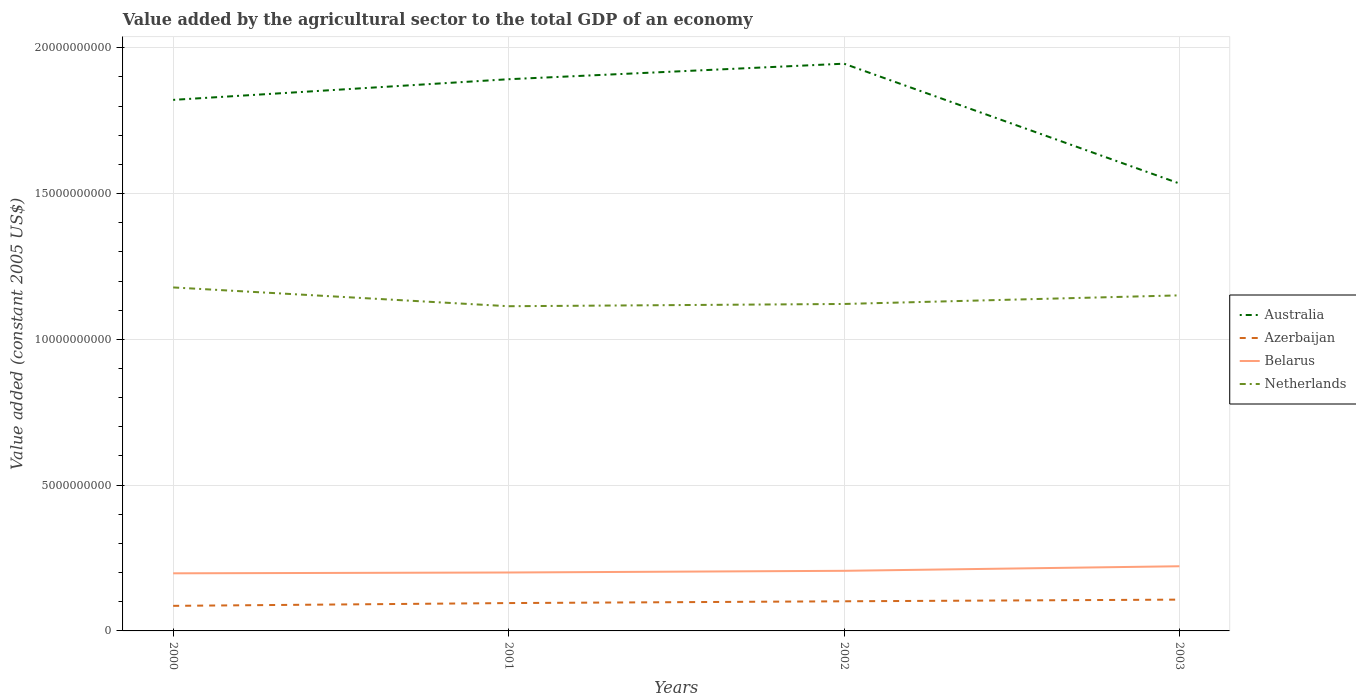How many different coloured lines are there?
Give a very brief answer. 4. Across all years, what is the maximum value added by the agricultural sector in Azerbaijan?
Ensure brevity in your answer.  8.60e+08. In which year was the value added by the agricultural sector in Azerbaijan maximum?
Make the answer very short. 2000. What is the total value added by the agricultural sector in Australia in the graph?
Your answer should be compact. 2.87e+09. What is the difference between the highest and the second highest value added by the agricultural sector in Belarus?
Provide a succinct answer. 2.42e+08. Is the value added by the agricultural sector in Azerbaijan strictly greater than the value added by the agricultural sector in Australia over the years?
Provide a short and direct response. Yes. How many years are there in the graph?
Ensure brevity in your answer.  4. Where does the legend appear in the graph?
Provide a short and direct response. Center right. What is the title of the graph?
Your answer should be very brief. Value added by the agricultural sector to the total GDP of an economy. What is the label or title of the Y-axis?
Provide a short and direct response. Value added (constant 2005 US$). What is the Value added (constant 2005 US$) of Australia in 2000?
Your answer should be compact. 1.82e+1. What is the Value added (constant 2005 US$) in Azerbaijan in 2000?
Your response must be concise. 8.60e+08. What is the Value added (constant 2005 US$) of Belarus in 2000?
Offer a terse response. 1.98e+09. What is the Value added (constant 2005 US$) of Netherlands in 2000?
Provide a short and direct response. 1.18e+1. What is the Value added (constant 2005 US$) in Australia in 2001?
Offer a terse response. 1.89e+1. What is the Value added (constant 2005 US$) of Azerbaijan in 2001?
Ensure brevity in your answer.  9.55e+08. What is the Value added (constant 2005 US$) of Belarus in 2001?
Your answer should be very brief. 2.00e+09. What is the Value added (constant 2005 US$) in Netherlands in 2001?
Your response must be concise. 1.11e+1. What is the Value added (constant 2005 US$) of Australia in 2002?
Provide a succinct answer. 1.95e+1. What is the Value added (constant 2005 US$) in Azerbaijan in 2002?
Make the answer very short. 1.02e+09. What is the Value added (constant 2005 US$) in Belarus in 2002?
Your response must be concise. 2.06e+09. What is the Value added (constant 2005 US$) of Netherlands in 2002?
Give a very brief answer. 1.12e+1. What is the Value added (constant 2005 US$) of Australia in 2003?
Keep it short and to the point. 1.53e+1. What is the Value added (constant 2005 US$) in Azerbaijan in 2003?
Your answer should be very brief. 1.07e+09. What is the Value added (constant 2005 US$) of Belarus in 2003?
Provide a short and direct response. 2.22e+09. What is the Value added (constant 2005 US$) of Netherlands in 2003?
Make the answer very short. 1.15e+1. Across all years, what is the maximum Value added (constant 2005 US$) of Australia?
Offer a very short reply. 1.95e+1. Across all years, what is the maximum Value added (constant 2005 US$) in Azerbaijan?
Offer a very short reply. 1.07e+09. Across all years, what is the maximum Value added (constant 2005 US$) in Belarus?
Provide a short and direct response. 2.22e+09. Across all years, what is the maximum Value added (constant 2005 US$) of Netherlands?
Ensure brevity in your answer.  1.18e+1. Across all years, what is the minimum Value added (constant 2005 US$) of Australia?
Give a very brief answer. 1.53e+1. Across all years, what is the minimum Value added (constant 2005 US$) of Azerbaijan?
Your response must be concise. 8.60e+08. Across all years, what is the minimum Value added (constant 2005 US$) of Belarus?
Keep it short and to the point. 1.98e+09. Across all years, what is the minimum Value added (constant 2005 US$) in Netherlands?
Give a very brief answer. 1.11e+1. What is the total Value added (constant 2005 US$) of Australia in the graph?
Offer a very short reply. 7.19e+1. What is the total Value added (constant 2005 US$) of Azerbaijan in the graph?
Ensure brevity in your answer.  3.91e+09. What is the total Value added (constant 2005 US$) in Belarus in the graph?
Your answer should be very brief. 8.26e+09. What is the total Value added (constant 2005 US$) in Netherlands in the graph?
Provide a short and direct response. 4.56e+1. What is the difference between the Value added (constant 2005 US$) of Australia in 2000 and that in 2001?
Your answer should be compact. -7.08e+08. What is the difference between the Value added (constant 2005 US$) of Azerbaijan in 2000 and that in 2001?
Make the answer very short. -9.54e+07. What is the difference between the Value added (constant 2005 US$) in Belarus in 2000 and that in 2001?
Your response must be concise. -2.81e+07. What is the difference between the Value added (constant 2005 US$) of Netherlands in 2000 and that in 2001?
Make the answer very short. 6.44e+08. What is the difference between the Value added (constant 2005 US$) in Australia in 2000 and that in 2002?
Your answer should be very brief. -1.24e+09. What is the difference between the Value added (constant 2005 US$) of Azerbaijan in 2000 and that in 2002?
Make the answer very short. -1.57e+08. What is the difference between the Value added (constant 2005 US$) of Belarus in 2000 and that in 2002?
Keep it short and to the point. -8.60e+07. What is the difference between the Value added (constant 2005 US$) in Netherlands in 2000 and that in 2002?
Your answer should be very brief. 5.67e+08. What is the difference between the Value added (constant 2005 US$) in Australia in 2000 and that in 2003?
Your response must be concise. 2.87e+09. What is the difference between the Value added (constant 2005 US$) of Azerbaijan in 2000 and that in 2003?
Make the answer very short. -2.14e+08. What is the difference between the Value added (constant 2005 US$) of Belarus in 2000 and that in 2003?
Make the answer very short. -2.42e+08. What is the difference between the Value added (constant 2005 US$) of Netherlands in 2000 and that in 2003?
Ensure brevity in your answer.  2.72e+08. What is the difference between the Value added (constant 2005 US$) of Australia in 2001 and that in 2002?
Keep it short and to the point. -5.33e+08. What is the difference between the Value added (constant 2005 US$) in Azerbaijan in 2001 and that in 2002?
Offer a very short reply. -6.11e+07. What is the difference between the Value added (constant 2005 US$) of Belarus in 2001 and that in 2002?
Your answer should be compact. -5.79e+07. What is the difference between the Value added (constant 2005 US$) of Netherlands in 2001 and that in 2002?
Offer a very short reply. -7.75e+07. What is the difference between the Value added (constant 2005 US$) in Australia in 2001 and that in 2003?
Your response must be concise. 3.58e+09. What is the difference between the Value added (constant 2005 US$) of Azerbaijan in 2001 and that in 2003?
Make the answer very short. -1.18e+08. What is the difference between the Value added (constant 2005 US$) of Belarus in 2001 and that in 2003?
Provide a succinct answer. -2.14e+08. What is the difference between the Value added (constant 2005 US$) of Netherlands in 2001 and that in 2003?
Provide a short and direct response. -3.72e+08. What is the difference between the Value added (constant 2005 US$) of Australia in 2002 and that in 2003?
Your answer should be very brief. 4.11e+09. What is the difference between the Value added (constant 2005 US$) in Azerbaijan in 2002 and that in 2003?
Your answer should be compact. -5.69e+07. What is the difference between the Value added (constant 2005 US$) in Belarus in 2002 and that in 2003?
Keep it short and to the point. -1.56e+08. What is the difference between the Value added (constant 2005 US$) of Netherlands in 2002 and that in 2003?
Your answer should be very brief. -2.95e+08. What is the difference between the Value added (constant 2005 US$) of Australia in 2000 and the Value added (constant 2005 US$) of Azerbaijan in 2001?
Offer a very short reply. 1.73e+1. What is the difference between the Value added (constant 2005 US$) of Australia in 2000 and the Value added (constant 2005 US$) of Belarus in 2001?
Offer a terse response. 1.62e+1. What is the difference between the Value added (constant 2005 US$) in Australia in 2000 and the Value added (constant 2005 US$) in Netherlands in 2001?
Make the answer very short. 7.08e+09. What is the difference between the Value added (constant 2005 US$) of Azerbaijan in 2000 and the Value added (constant 2005 US$) of Belarus in 2001?
Your answer should be compact. -1.14e+09. What is the difference between the Value added (constant 2005 US$) of Azerbaijan in 2000 and the Value added (constant 2005 US$) of Netherlands in 2001?
Your answer should be compact. -1.03e+1. What is the difference between the Value added (constant 2005 US$) in Belarus in 2000 and the Value added (constant 2005 US$) in Netherlands in 2001?
Offer a very short reply. -9.16e+09. What is the difference between the Value added (constant 2005 US$) in Australia in 2000 and the Value added (constant 2005 US$) in Azerbaijan in 2002?
Your answer should be compact. 1.72e+1. What is the difference between the Value added (constant 2005 US$) of Australia in 2000 and the Value added (constant 2005 US$) of Belarus in 2002?
Ensure brevity in your answer.  1.62e+1. What is the difference between the Value added (constant 2005 US$) in Australia in 2000 and the Value added (constant 2005 US$) in Netherlands in 2002?
Offer a very short reply. 7.00e+09. What is the difference between the Value added (constant 2005 US$) in Azerbaijan in 2000 and the Value added (constant 2005 US$) in Belarus in 2002?
Keep it short and to the point. -1.20e+09. What is the difference between the Value added (constant 2005 US$) in Azerbaijan in 2000 and the Value added (constant 2005 US$) in Netherlands in 2002?
Keep it short and to the point. -1.04e+1. What is the difference between the Value added (constant 2005 US$) in Belarus in 2000 and the Value added (constant 2005 US$) in Netherlands in 2002?
Your answer should be compact. -9.24e+09. What is the difference between the Value added (constant 2005 US$) of Australia in 2000 and the Value added (constant 2005 US$) of Azerbaijan in 2003?
Your response must be concise. 1.71e+1. What is the difference between the Value added (constant 2005 US$) of Australia in 2000 and the Value added (constant 2005 US$) of Belarus in 2003?
Offer a terse response. 1.60e+1. What is the difference between the Value added (constant 2005 US$) of Australia in 2000 and the Value added (constant 2005 US$) of Netherlands in 2003?
Make the answer very short. 6.70e+09. What is the difference between the Value added (constant 2005 US$) in Azerbaijan in 2000 and the Value added (constant 2005 US$) in Belarus in 2003?
Provide a short and direct response. -1.36e+09. What is the difference between the Value added (constant 2005 US$) of Azerbaijan in 2000 and the Value added (constant 2005 US$) of Netherlands in 2003?
Offer a very short reply. -1.06e+1. What is the difference between the Value added (constant 2005 US$) in Belarus in 2000 and the Value added (constant 2005 US$) in Netherlands in 2003?
Make the answer very short. -9.53e+09. What is the difference between the Value added (constant 2005 US$) in Australia in 2001 and the Value added (constant 2005 US$) in Azerbaijan in 2002?
Provide a succinct answer. 1.79e+1. What is the difference between the Value added (constant 2005 US$) in Australia in 2001 and the Value added (constant 2005 US$) in Belarus in 2002?
Offer a terse response. 1.69e+1. What is the difference between the Value added (constant 2005 US$) in Australia in 2001 and the Value added (constant 2005 US$) in Netherlands in 2002?
Give a very brief answer. 7.71e+09. What is the difference between the Value added (constant 2005 US$) in Azerbaijan in 2001 and the Value added (constant 2005 US$) in Belarus in 2002?
Your response must be concise. -1.11e+09. What is the difference between the Value added (constant 2005 US$) of Azerbaijan in 2001 and the Value added (constant 2005 US$) of Netherlands in 2002?
Your answer should be very brief. -1.03e+1. What is the difference between the Value added (constant 2005 US$) in Belarus in 2001 and the Value added (constant 2005 US$) in Netherlands in 2002?
Your answer should be compact. -9.21e+09. What is the difference between the Value added (constant 2005 US$) of Australia in 2001 and the Value added (constant 2005 US$) of Azerbaijan in 2003?
Keep it short and to the point. 1.78e+1. What is the difference between the Value added (constant 2005 US$) of Australia in 2001 and the Value added (constant 2005 US$) of Belarus in 2003?
Offer a very short reply. 1.67e+1. What is the difference between the Value added (constant 2005 US$) in Australia in 2001 and the Value added (constant 2005 US$) in Netherlands in 2003?
Give a very brief answer. 7.41e+09. What is the difference between the Value added (constant 2005 US$) of Azerbaijan in 2001 and the Value added (constant 2005 US$) of Belarus in 2003?
Provide a short and direct response. -1.26e+09. What is the difference between the Value added (constant 2005 US$) of Azerbaijan in 2001 and the Value added (constant 2005 US$) of Netherlands in 2003?
Offer a terse response. -1.06e+1. What is the difference between the Value added (constant 2005 US$) in Belarus in 2001 and the Value added (constant 2005 US$) in Netherlands in 2003?
Ensure brevity in your answer.  -9.51e+09. What is the difference between the Value added (constant 2005 US$) of Australia in 2002 and the Value added (constant 2005 US$) of Azerbaijan in 2003?
Offer a very short reply. 1.84e+1. What is the difference between the Value added (constant 2005 US$) of Australia in 2002 and the Value added (constant 2005 US$) of Belarus in 2003?
Your response must be concise. 1.72e+1. What is the difference between the Value added (constant 2005 US$) of Australia in 2002 and the Value added (constant 2005 US$) of Netherlands in 2003?
Ensure brevity in your answer.  7.95e+09. What is the difference between the Value added (constant 2005 US$) in Azerbaijan in 2002 and the Value added (constant 2005 US$) in Belarus in 2003?
Make the answer very short. -1.20e+09. What is the difference between the Value added (constant 2005 US$) of Azerbaijan in 2002 and the Value added (constant 2005 US$) of Netherlands in 2003?
Offer a very short reply. -1.05e+1. What is the difference between the Value added (constant 2005 US$) in Belarus in 2002 and the Value added (constant 2005 US$) in Netherlands in 2003?
Your response must be concise. -9.45e+09. What is the average Value added (constant 2005 US$) of Australia per year?
Provide a short and direct response. 1.80e+1. What is the average Value added (constant 2005 US$) of Azerbaijan per year?
Provide a succinct answer. 9.76e+08. What is the average Value added (constant 2005 US$) of Belarus per year?
Provide a succinct answer. 2.06e+09. What is the average Value added (constant 2005 US$) of Netherlands per year?
Your answer should be very brief. 1.14e+1. In the year 2000, what is the difference between the Value added (constant 2005 US$) in Australia and Value added (constant 2005 US$) in Azerbaijan?
Your answer should be very brief. 1.74e+1. In the year 2000, what is the difference between the Value added (constant 2005 US$) in Australia and Value added (constant 2005 US$) in Belarus?
Keep it short and to the point. 1.62e+1. In the year 2000, what is the difference between the Value added (constant 2005 US$) in Australia and Value added (constant 2005 US$) in Netherlands?
Keep it short and to the point. 6.43e+09. In the year 2000, what is the difference between the Value added (constant 2005 US$) of Azerbaijan and Value added (constant 2005 US$) of Belarus?
Make the answer very short. -1.12e+09. In the year 2000, what is the difference between the Value added (constant 2005 US$) of Azerbaijan and Value added (constant 2005 US$) of Netherlands?
Give a very brief answer. -1.09e+1. In the year 2000, what is the difference between the Value added (constant 2005 US$) in Belarus and Value added (constant 2005 US$) in Netherlands?
Give a very brief answer. -9.81e+09. In the year 2001, what is the difference between the Value added (constant 2005 US$) of Australia and Value added (constant 2005 US$) of Azerbaijan?
Your response must be concise. 1.80e+1. In the year 2001, what is the difference between the Value added (constant 2005 US$) in Australia and Value added (constant 2005 US$) in Belarus?
Give a very brief answer. 1.69e+1. In the year 2001, what is the difference between the Value added (constant 2005 US$) of Australia and Value added (constant 2005 US$) of Netherlands?
Your answer should be compact. 7.79e+09. In the year 2001, what is the difference between the Value added (constant 2005 US$) of Azerbaijan and Value added (constant 2005 US$) of Belarus?
Ensure brevity in your answer.  -1.05e+09. In the year 2001, what is the difference between the Value added (constant 2005 US$) of Azerbaijan and Value added (constant 2005 US$) of Netherlands?
Ensure brevity in your answer.  -1.02e+1. In the year 2001, what is the difference between the Value added (constant 2005 US$) of Belarus and Value added (constant 2005 US$) of Netherlands?
Provide a short and direct response. -9.13e+09. In the year 2002, what is the difference between the Value added (constant 2005 US$) in Australia and Value added (constant 2005 US$) in Azerbaijan?
Provide a short and direct response. 1.84e+1. In the year 2002, what is the difference between the Value added (constant 2005 US$) in Australia and Value added (constant 2005 US$) in Belarus?
Make the answer very short. 1.74e+1. In the year 2002, what is the difference between the Value added (constant 2005 US$) in Australia and Value added (constant 2005 US$) in Netherlands?
Offer a terse response. 8.24e+09. In the year 2002, what is the difference between the Value added (constant 2005 US$) in Azerbaijan and Value added (constant 2005 US$) in Belarus?
Keep it short and to the point. -1.05e+09. In the year 2002, what is the difference between the Value added (constant 2005 US$) in Azerbaijan and Value added (constant 2005 US$) in Netherlands?
Make the answer very short. -1.02e+1. In the year 2002, what is the difference between the Value added (constant 2005 US$) in Belarus and Value added (constant 2005 US$) in Netherlands?
Provide a short and direct response. -9.15e+09. In the year 2003, what is the difference between the Value added (constant 2005 US$) of Australia and Value added (constant 2005 US$) of Azerbaijan?
Offer a very short reply. 1.43e+1. In the year 2003, what is the difference between the Value added (constant 2005 US$) in Australia and Value added (constant 2005 US$) in Belarus?
Offer a terse response. 1.31e+1. In the year 2003, what is the difference between the Value added (constant 2005 US$) in Australia and Value added (constant 2005 US$) in Netherlands?
Offer a very short reply. 3.84e+09. In the year 2003, what is the difference between the Value added (constant 2005 US$) of Azerbaijan and Value added (constant 2005 US$) of Belarus?
Keep it short and to the point. -1.14e+09. In the year 2003, what is the difference between the Value added (constant 2005 US$) in Azerbaijan and Value added (constant 2005 US$) in Netherlands?
Provide a short and direct response. -1.04e+1. In the year 2003, what is the difference between the Value added (constant 2005 US$) in Belarus and Value added (constant 2005 US$) in Netherlands?
Your response must be concise. -9.29e+09. What is the ratio of the Value added (constant 2005 US$) in Australia in 2000 to that in 2001?
Provide a short and direct response. 0.96. What is the ratio of the Value added (constant 2005 US$) of Azerbaijan in 2000 to that in 2001?
Offer a very short reply. 0.9. What is the ratio of the Value added (constant 2005 US$) in Belarus in 2000 to that in 2001?
Provide a short and direct response. 0.99. What is the ratio of the Value added (constant 2005 US$) of Netherlands in 2000 to that in 2001?
Your answer should be compact. 1.06. What is the ratio of the Value added (constant 2005 US$) of Australia in 2000 to that in 2002?
Your response must be concise. 0.94. What is the ratio of the Value added (constant 2005 US$) of Azerbaijan in 2000 to that in 2002?
Ensure brevity in your answer.  0.85. What is the ratio of the Value added (constant 2005 US$) in Belarus in 2000 to that in 2002?
Your response must be concise. 0.96. What is the ratio of the Value added (constant 2005 US$) in Netherlands in 2000 to that in 2002?
Make the answer very short. 1.05. What is the ratio of the Value added (constant 2005 US$) of Australia in 2000 to that in 2003?
Ensure brevity in your answer.  1.19. What is the ratio of the Value added (constant 2005 US$) in Azerbaijan in 2000 to that in 2003?
Offer a terse response. 0.8. What is the ratio of the Value added (constant 2005 US$) of Belarus in 2000 to that in 2003?
Offer a terse response. 0.89. What is the ratio of the Value added (constant 2005 US$) of Netherlands in 2000 to that in 2003?
Offer a terse response. 1.02. What is the ratio of the Value added (constant 2005 US$) of Australia in 2001 to that in 2002?
Offer a terse response. 0.97. What is the ratio of the Value added (constant 2005 US$) of Azerbaijan in 2001 to that in 2002?
Provide a short and direct response. 0.94. What is the ratio of the Value added (constant 2005 US$) of Belarus in 2001 to that in 2002?
Your answer should be compact. 0.97. What is the ratio of the Value added (constant 2005 US$) of Netherlands in 2001 to that in 2002?
Offer a very short reply. 0.99. What is the ratio of the Value added (constant 2005 US$) of Australia in 2001 to that in 2003?
Offer a very short reply. 1.23. What is the ratio of the Value added (constant 2005 US$) of Azerbaijan in 2001 to that in 2003?
Make the answer very short. 0.89. What is the ratio of the Value added (constant 2005 US$) in Belarus in 2001 to that in 2003?
Your answer should be compact. 0.9. What is the ratio of the Value added (constant 2005 US$) of Netherlands in 2001 to that in 2003?
Ensure brevity in your answer.  0.97. What is the ratio of the Value added (constant 2005 US$) in Australia in 2002 to that in 2003?
Offer a very short reply. 1.27. What is the ratio of the Value added (constant 2005 US$) of Azerbaijan in 2002 to that in 2003?
Offer a very short reply. 0.95. What is the ratio of the Value added (constant 2005 US$) in Belarus in 2002 to that in 2003?
Give a very brief answer. 0.93. What is the ratio of the Value added (constant 2005 US$) in Netherlands in 2002 to that in 2003?
Offer a terse response. 0.97. What is the difference between the highest and the second highest Value added (constant 2005 US$) of Australia?
Offer a very short reply. 5.33e+08. What is the difference between the highest and the second highest Value added (constant 2005 US$) of Azerbaijan?
Provide a short and direct response. 5.69e+07. What is the difference between the highest and the second highest Value added (constant 2005 US$) in Belarus?
Give a very brief answer. 1.56e+08. What is the difference between the highest and the second highest Value added (constant 2005 US$) of Netherlands?
Provide a succinct answer. 2.72e+08. What is the difference between the highest and the lowest Value added (constant 2005 US$) of Australia?
Your response must be concise. 4.11e+09. What is the difference between the highest and the lowest Value added (constant 2005 US$) in Azerbaijan?
Your answer should be very brief. 2.14e+08. What is the difference between the highest and the lowest Value added (constant 2005 US$) of Belarus?
Offer a very short reply. 2.42e+08. What is the difference between the highest and the lowest Value added (constant 2005 US$) of Netherlands?
Offer a very short reply. 6.44e+08. 